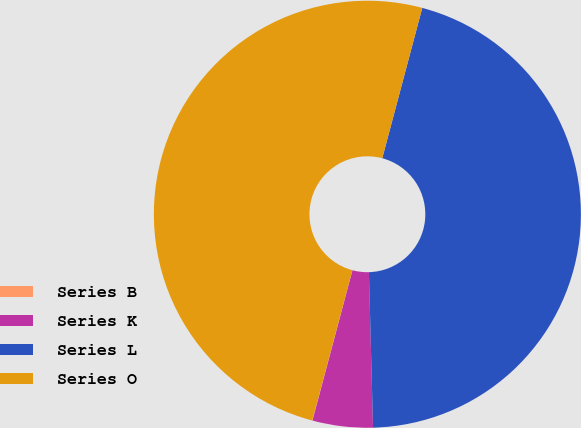Convert chart. <chart><loc_0><loc_0><loc_500><loc_500><pie_chart><fcel>Series B<fcel>Series K<fcel>Series L<fcel>Series O<nl><fcel>0.02%<fcel>4.56%<fcel>45.44%<fcel>49.98%<nl></chart> 